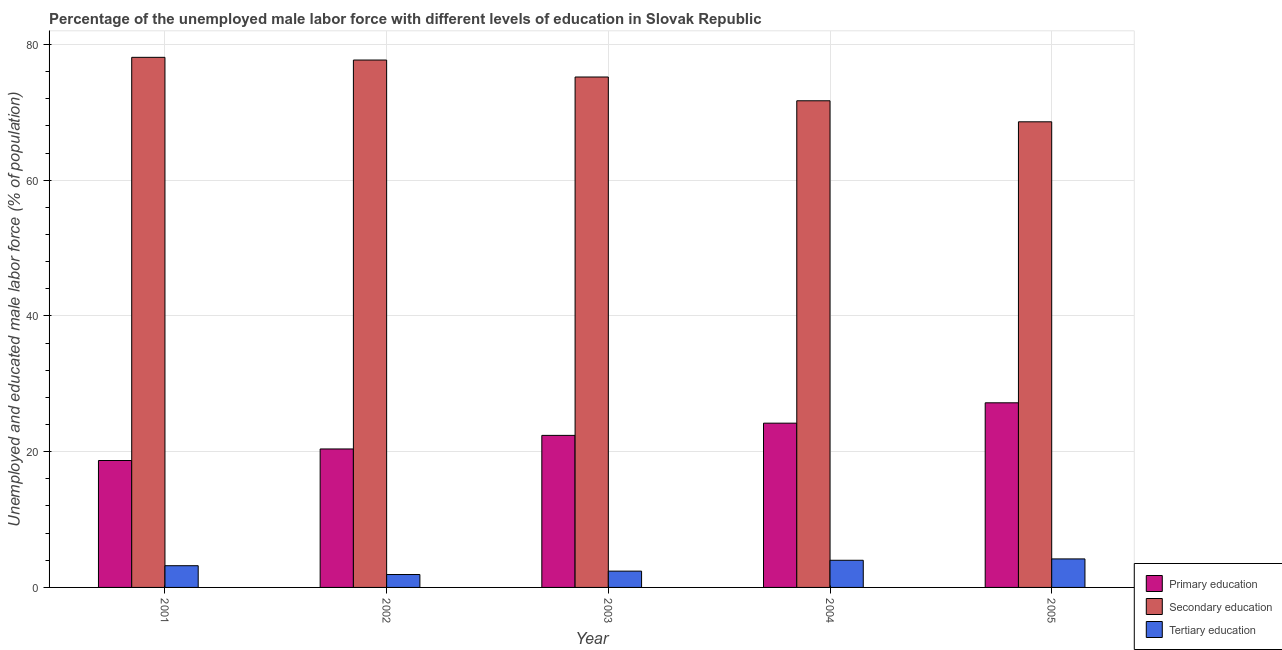How many different coloured bars are there?
Offer a very short reply. 3. Are the number of bars on each tick of the X-axis equal?
Make the answer very short. Yes. How many bars are there on the 3rd tick from the left?
Keep it short and to the point. 3. What is the label of the 3rd group of bars from the left?
Ensure brevity in your answer.  2003. What is the percentage of male labor force who received primary education in 2004?
Provide a short and direct response. 24.2. Across all years, what is the maximum percentage of male labor force who received secondary education?
Offer a terse response. 78.1. Across all years, what is the minimum percentage of male labor force who received primary education?
Provide a short and direct response. 18.7. In which year was the percentage of male labor force who received tertiary education minimum?
Give a very brief answer. 2002. What is the total percentage of male labor force who received tertiary education in the graph?
Offer a very short reply. 15.7. What is the difference between the percentage of male labor force who received tertiary education in 2002 and that in 2004?
Keep it short and to the point. -2.1. What is the difference between the percentage of male labor force who received secondary education in 2001 and the percentage of male labor force who received primary education in 2002?
Provide a succinct answer. 0.4. What is the average percentage of male labor force who received primary education per year?
Provide a short and direct response. 22.58. In how many years, is the percentage of male labor force who received primary education greater than 64 %?
Your answer should be very brief. 0. What is the ratio of the percentage of male labor force who received secondary education in 2002 to that in 2005?
Ensure brevity in your answer.  1.13. Is the difference between the percentage of male labor force who received primary education in 2004 and 2005 greater than the difference between the percentage of male labor force who received secondary education in 2004 and 2005?
Provide a short and direct response. No. What is the difference between the highest and the lowest percentage of male labor force who received tertiary education?
Give a very brief answer. 2.3. Is the sum of the percentage of male labor force who received tertiary education in 2001 and 2004 greater than the maximum percentage of male labor force who received secondary education across all years?
Make the answer very short. Yes. What does the 2nd bar from the left in 2004 represents?
Provide a short and direct response. Secondary education. What does the 1st bar from the right in 2005 represents?
Your response must be concise. Tertiary education. What is the difference between two consecutive major ticks on the Y-axis?
Offer a very short reply. 20. Does the graph contain any zero values?
Offer a very short reply. No. Does the graph contain grids?
Your response must be concise. Yes. Where does the legend appear in the graph?
Give a very brief answer. Bottom right. How many legend labels are there?
Offer a terse response. 3. What is the title of the graph?
Keep it short and to the point. Percentage of the unemployed male labor force with different levels of education in Slovak Republic. What is the label or title of the Y-axis?
Make the answer very short. Unemployed and educated male labor force (% of population). What is the Unemployed and educated male labor force (% of population) of Primary education in 2001?
Provide a succinct answer. 18.7. What is the Unemployed and educated male labor force (% of population) of Secondary education in 2001?
Give a very brief answer. 78.1. What is the Unemployed and educated male labor force (% of population) of Tertiary education in 2001?
Ensure brevity in your answer.  3.2. What is the Unemployed and educated male labor force (% of population) of Primary education in 2002?
Offer a very short reply. 20.4. What is the Unemployed and educated male labor force (% of population) of Secondary education in 2002?
Offer a very short reply. 77.7. What is the Unemployed and educated male labor force (% of population) in Tertiary education in 2002?
Give a very brief answer. 1.9. What is the Unemployed and educated male labor force (% of population) of Primary education in 2003?
Your answer should be very brief. 22.4. What is the Unemployed and educated male labor force (% of population) of Secondary education in 2003?
Offer a terse response. 75.2. What is the Unemployed and educated male labor force (% of population) of Tertiary education in 2003?
Ensure brevity in your answer.  2.4. What is the Unemployed and educated male labor force (% of population) of Primary education in 2004?
Provide a succinct answer. 24.2. What is the Unemployed and educated male labor force (% of population) of Secondary education in 2004?
Your answer should be very brief. 71.7. What is the Unemployed and educated male labor force (% of population) in Tertiary education in 2004?
Your response must be concise. 4. What is the Unemployed and educated male labor force (% of population) in Primary education in 2005?
Your response must be concise. 27.2. What is the Unemployed and educated male labor force (% of population) of Secondary education in 2005?
Your response must be concise. 68.6. What is the Unemployed and educated male labor force (% of population) of Tertiary education in 2005?
Provide a short and direct response. 4.2. Across all years, what is the maximum Unemployed and educated male labor force (% of population) in Primary education?
Give a very brief answer. 27.2. Across all years, what is the maximum Unemployed and educated male labor force (% of population) of Secondary education?
Provide a short and direct response. 78.1. Across all years, what is the maximum Unemployed and educated male labor force (% of population) of Tertiary education?
Provide a succinct answer. 4.2. Across all years, what is the minimum Unemployed and educated male labor force (% of population) of Primary education?
Provide a short and direct response. 18.7. Across all years, what is the minimum Unemployed and educated male labor force (% of population) in Secondary education?
Your answer should be very brief. 68.6. Across all years, what is the minimum Unemployed and educated male labor force (% of population) of Tertiary education?
Make the answer very short. 1.9. What is the total Unemployed and educated male labor force (% of population) of Primary education in the graph?
Provide a succinct answer. 112.9. What is the total Unemployed and educated male labor force (% of population) in Secondary education in the graph?
Your response must be concise. 371.3. What is the difference between the Unemployed and educated male labor force (% of population) in Primary education in 2001 and that in 2002?
Provide a succinct answer. -1.7. What is the difference between the Unemployed and educated male labor force (% of population) of Secondary education in 2001 and that in 2002?
Offer a very short reply. 0.4. What is the difference between the Unemployed and educated male labor force (% of population) of Primary education in 2001 and that in 2003?
Offer a very short reply. -3.7. What is the difference between the Unemployed and educated male labor force (% of population) of Secondary education in 2001 and that in 2003?
Give a very brief answer. 2.9. What is the difference between the Unemployed and educated male labor force (% of population) of Secondary education in 2001 and that in 2004?
Your answer should be compact. 6.4. What is the difference between the Unemployed and educated male labor force (% of population) of Tertiary education in 2001 and that in 2004?
Make the answer very short. -0.8. What is the difference between the Unemployed and educated male labor force (% of population) in Secondary education in 2001 and that in 2005?
Offer a very short reply. 9.5. What is the difference between the Unemployed and educated male labor force (% of population) of Tertiary education in 2001 and that in 2005?
Offer a very short reply. -1. What is the difference between the Unemployed and educated male labor force (% of population) of Secondary education in 2002 and that in 2004?
Offer a very short reply. 6. What is the difference between the Unemployed and educated male labor force (% of population) in Primary education in 2002 and that in 2005?
Provide a short and direct response. -6.8. What is the difference between the Unemployed and educated male labor force (% of population) of Tertiary education in 2002 and that in 2005?
Make the answer very short. -2.3. What is the difference between the Unemployed and educated male labor force (% of population) in Primary education in 2003 and that in 2004?
Provide a succinct answer. -1.8. What is the difference between the Unemployed and educated male labor force (% of population) of Secondary education in 2003 and that in 2004?
Provide a succinct answer. 3.5. What is the difference between the Unemployed and educated male labor force (% of population) of Primary education in 2004 and that in 2005?
Your answer should be compact. -3. What is the difference between the Unemployed and educated male labor force (% of population) of Secondary education in 2004 and that in 2005?
Your answer should be very brief. 3.1. What is the difference between the Unemployed and educated male labor force (% of population) in Primary education in 2001 and the Unemployed and educated male labor force (% of population) in Secondary education in 2002?
Your answer should be very brief. -59. What is the difference between the Unemployed and educated male labor force (% of population) in Primary education in 2001 and the Unemployed and educated male labor force (% of population) in Tertiary education in 2002?
Offer a terse response. 16.8. What is the difference between the Unemployed and educated male labor force (% of population) of Secondary education in 2001 and the Unemployed and educated male labor force (% of population) of Tertiary education in 2002?
Give a very brief answer. 76.2. What is the difference between the Unemployed and educated male labor force (% of population) of Primary education in 2001 and the Unemployed and educated male labor force (% of population) of Secondary education in 2003?
Offer a terse response. -56.5. What is the difference between the Unemployed and educated male labor force (% of population) of Primary education in 2001 and the Unemployed and educated male labor force (% of population) of Tertiary education in 2003?
Keep it short and to the point. 16.3. What is the difference between the Unemployed and educated male labor force (% of population) of Secondary education in 2001 and the Unemployed and educated male labor force (% of population) of Tertiary education in 2003?
Provide a succinct answer. 75.7. What is the difference between the Unemployed and educated male labor force (% of population) of Primary education in 2001 and the Unemployed and educated male labor force (% of population) of Secondary education in 2004?
Make the answer very short. -53. What is the difference between the Unemployed and educated male labor force (% of population) of Primary education in 2001 and the Unemployed and educated male labor force (% of population) of Tertiary education in 2004?
Offer a very short reply. 14.7. What is the difference between the Unemployed and educated male labor force (% of population) of Secondary education in 2001 and the Unemployed and educated male labor force (% of population) of Tertiary education in 2004?
Give a very brief answer. 74.1. What is the difference between the Unemployed and educated male labor force (% of population) of Primary education in 2001 and the Unemployed and educated male labor force (% of population) of Secondary education in 2005?
Your answer should be compact. -49.9. What is the difference between the Unemployed and educated male labor force (% of population) in Primary education in 2001 and the Unemployed and educated male labor force (% of population) in Tertiary education in 2005?
Provide a succinct answer. 14.5. What is the difference between the Unemployed and educated male labor force (% of population) of Secondary education in 2001 and the Unemployed and educated male labor force (% of population) of Tertiary education in 2005?
Your answer should be very brief. 73.9. What is the difference between the Unemployed and educated male labor force (% of population) of Primary education in 2002 and the Unemployed and educated male labor force (% of population) of Secondary education in 2003?
Provide a short and direct response. -54.8. What is the difference between the Unemployed and educated male labor force (% of population) of Primary education in 2002 and the Unemployed and educated male labor force (% of population) of Tertiary education in 2003?
Keep it short and to the point. 18. What is the difference between the Unemployed and educated male labor force (% of population) of Secondary education in 2002 and the Unemployed and educated male labor force (% of population) of Tertiary education in 2003?
Ensure brevity in your answer.  75.3. What is the difference between the Unemployed and educated male labor force (% of population) of Primary education in 2002 and the Unemployed and educated male labor force (% of population) of Secondary education in 2004?
Your response must be concise. -51.3. What is the difference between the Unemployed and educated male labor force (% of population) of Secondary education in 2002 and the Unemployed and educated male labor force (% of population) of Tertiary education in 2004?
Provide a succinct answer. 73.7. What is the difference between the Unemployed and educated male labor force (% of population) in Primary education in 2002 and the Unemployed and educated male labor force (% of population) in Secondary education in 2005?
Ensure brevity in your answer.  -48.2. What is the difference between the Unemployed and educated male labor force (% of population) in Primary education in 2002 and the Unemployed and educated male labor force (% of population) in Tertiary education in 2005?
Make the answer very short. 16.2. What is the difference between the Unemployed and educated male labor force (% of population) of Secondary education in 2002 and the Unemployed and educated male labor force (% of population) of Tertiary education in 2005?
Your response must be concise. 73.5. What is the difference between the Unemployed and educated male labor force (% of population) in Primary education in 2003 and the Unemployed and educated male labor force (% of population) in Secondary education in 2004?
Keep it short and to the point. -49.3. What is the difference between the Unemployed and educated male labor force (% of population) in Primary education in 2003 and the Unemployed and educated male labor force (% of population) in Tertiary education in 2004?
Provide a succinct answer. 18.4. What is the difference between the Unemployed and educated male labor force (% of population) of Secondary education in 2003 and the Unemployed and educated male labor force (% of population) of Tertiary education in 2004?
Your response must be concise. 71.2. What is the difference between the Unemployed and educated male labor force (% of population) in Primary education in 2003 and the Unemployed and educated male labor force (% of population) in Secondary education in 2005?
Offer a very short reply. -46.2. What is the difference between the Unemployed and educated male labor force (% of population) of Secondary education in 2003 and the Unemployed and educated male labor force (% of population) of Tertiary education in 2005?
Offer a terse response. 71. What is the difference between the Unemployed and educated male labor force (% of population) in Primary education in 2004 and the Unemployed and educated male labor force (% of population) in Secondary education in 2005?
Provide a succinct answer. -44.4. What is the difference between the Unemployed and educated male labor force (% of population) of Primary education in 2004 and the Unemployed and educated male labor force (% of population) of Tertiary education in 2005?
Ensure brevity in your answer.  20. What is the difference between the Unemployed and educated male labor force (% of population) in Secondary education in 2004 and the Unemployed and educated male labor force (% of population) in Tertiary education in 2005?
Keep it short and to the point. 67.5. What is the average Unemployed and educated male labor force (% of population) in Primary education per year?
Your answer should be compact. 22.58. What is the average Unemployed and educated male labor force (% of population) in Secondary education per year?
Your answer should be very brief. 74.26. What is the average Unemployed and educated male labor force (% of population) in Tertiary education per year?
Offer a very short reply. 3.14. In the year 2001, what is the difference between the Unemployed and educated male labor force (% of population) of Primary education and Unemployed and educated male labor force (% of population) of Secondary education?
Your answer should be compact. -59.4. In the year 2001, what is the difference between the Unemployed and educated male labor force (% of population) of Secondary education and Unemployed and educated male labor force (% of population) of Tertiary education?
Keep it short and to the point. 74.9. In the year 2002, what is the difference between the Unemployed and educated male labor force (% of population) of Primary education and Unemployed and educated male labor force (% of population) of Secondary education?
Your answer should be very brief. -57.3. In the year 2002, what is the difference between the Unemployed and educated male labor force (% of population) in Primary education and Unemployed and educated male labor force (% of population) in Tertiary education?
Offer a terse response. 18.5. In the year 2002, what is the difference between the Unemployed and educated male labor force (% of population) of Secondary education and Unemployed and educated male labor force (% of population) of Tertiary education?
Provide a short and direct response. 75.8. In the year 2003, what is the difference between the Unemployed and educated male labor force (% of population) in Primary education and Unemployed and educated male labor force (% of population) in Secondary education?
Offer a terse response. -52.8. In the year 2003, what is the difference between the Unemployed and educated male labor force (% of population) in Primary education and Unemployed and educated male labor force (% of population) in Tertiary education?
Offer a terse response. 20. In the year 2003, what is the difference between the Unemployed and educated male labor force (% of population) of Secondary education and Unemployed and educated male labor force (% of population) of Tertiary education?
Your response must be concise. 72.8. In the year 2004, what is the difference between the Unemployed and educated male labor force (% of population) in Primary education and Unemployed and educated male labor force (% of population) in Secondary education?
Give a very brief answer. -47.5. In the year 2004, what is the difference between the Unemployed and educated male labor force (% of population) in Primary education and Unemployed and educated male labor force (% of population) in Tertiary education?
Make the answer very short. 20.2. In the year 2004, what is the difference between the Unemployed and educated male labor force (% of population) in Secondary education and Unemployed and educated male labor force (% of population) in Tertiary education?
Your answer should be very brief. 67.7. In the year 2005, what is the difference between the Unemployed and educated male labor force (% of population) of Primary education and Unemployed and educated male labor force (% of population) of Secondary education?
Make the answer very short. -41.4. In the year 2005, what is the difference between the Unemployed and educated male labor force (% of population) in Secondary education and Unemployed and educated male labor force (% of population) in Tertiary education?
Offer a very short reply. 64.4. What is the ratio of the Unemployed and educated male labor force (% of population) in Tertiary education in 2001 to that in 2002?
Your answer should be very brief. 1.68. What is the ratio of the Unemployed and educated male labor force (% of population) in Primary education in 2001 to that in 2003?
Your answer should be very brief. 0.83. What is the ratio of the Unemployed and educated male labor force (% of population) of Secondary education in 2001 to that in 2003?
Ensure brevity in your answer.  1.04. What is the ratio of the Unemployed and educated male labor force (% of population) of Tertiary education in 2001 to that in 2003?
Offer a terse response. 1.33. What is the ratio of the Unemployed and educated male labor force (% of population) in Primary education in 2001 to that in 2004?
Provide a succinct answer. 0.77. What is the ratio of the Unemployed and educated male labor force (% of population) in Secondary education in 2001 to that in 2004?
Provide a succinct answer. 1.09. What is the ratio of the Unemployed and educated male labor force (% of population) of Primary education in 2001 to that in 2005?
Ensure brevity in your answer.  0.69. What is the ratio of the Unemployed and educated male labor force (% of population) in Secondary education in 2001 to that in 2005?
Provide a short and direct response. 1.14. What is the ratio of the Unemployed and educated male labor force (% of population) of Tertiary education in 2001 to that in 2005?
Your answer should be very brief. 0.76. What is the ratio of the Unemployed and educated male labor force (% of population) in Primary education in 2002 to that in 2003?
Give a very brief answer. 0.91. What is the ratio of the Unemployed and educated male labor force (% of population) in Secondary education in 2002 to that in 2003?
Provide a succinct answer. 1.03. What is the ratio of the Unemployed and educated male labor force (% of population) of Tertiary education in 2002 to that in 2003?
Offer a terse response. 0.79. What is the ratio of the Unemployed and educated male labor force (% of population) in Primary education in 2002 to that in 2004?
Provide a short and direct response. 0.84. What is the ratio of the Unemployed and educated male labor force (% of population) of Secondary education in 2002 to that in 2004?
Offer a very short reply. 1.08. What is the ratio of the Unemployed and educated male labor force (% of population) in Tertiary education in 2002 to that in 2004?
Offer a terse response. 0.47. What is the ratio of the Unemployed and educated male labor force (% of population) in Primary education in 2002 to that in 2005?
Provide a short and direct response. 0.75. What is the ratio of the Unemployed and educated male labor force (% of population) in Secondary education in 2002 to that in 2005?
Give a very brief answer. 1.13. What is the ratio of the Unemployed and educated male labor force (% of population) in Tertiary education in 2002 to that in 2005?
Provide a succinct answer. 0.45. What is the ratio of the Unemployed and educated male labor force (% of population) of Primary education in 2003 to that in 2004?
Your answer should be compact. 0.93. What is the ratio of the Unemployed and educated male labor force (% of population) of Secondary education in 2003 to that in 2004?
Give a very brief answer. 1.05. What is the ratio of the Unemployed and educated male labor force (% of population) of Primary education in 2003 to that in 2005?
Offer a very short reply. 0.82. What is the ratio of the Unemployed and educated male labor force (% of population) in Secondary education in 2003 to that in 2005?
Give a very brief answer. 1.1. What is the ratio of the Unemployed and educated male labor force (% of population) in Tertiary education in 2003 to that in 2005?
Your response must be concise. 0.57. What is the ratio of the Unemployed and educated male labor force (% of population) of Primary education in 2004 to that in 2005?
Your answer should be compact. 0.89. What is the ratio of the Unemployed and educated male labor force (% of population) of Secondary education in 2004 to that in 2005?
Ensure brevity in your answer.  1.05. What is the ratio of the Unemployed and educated male labor force (% of population) in Tertiary education in 2004 to that in 2005?
Provide a succinct answer. 0.95. What is the difference between the highest and the second highest Unemployed and educated male labor force (% of population) in Primary education?
Your response must be concise. 3. What is the difference between the highest and the second highest Unemployed and educated male labor force (% of population) of Secondary education?
Provide a short and direct response. 0.4. What is the difference between the highest and the lowest Unemployed and educated male labor force (% of population) of Secondary education?
Give a very brief answer. 9.5. 